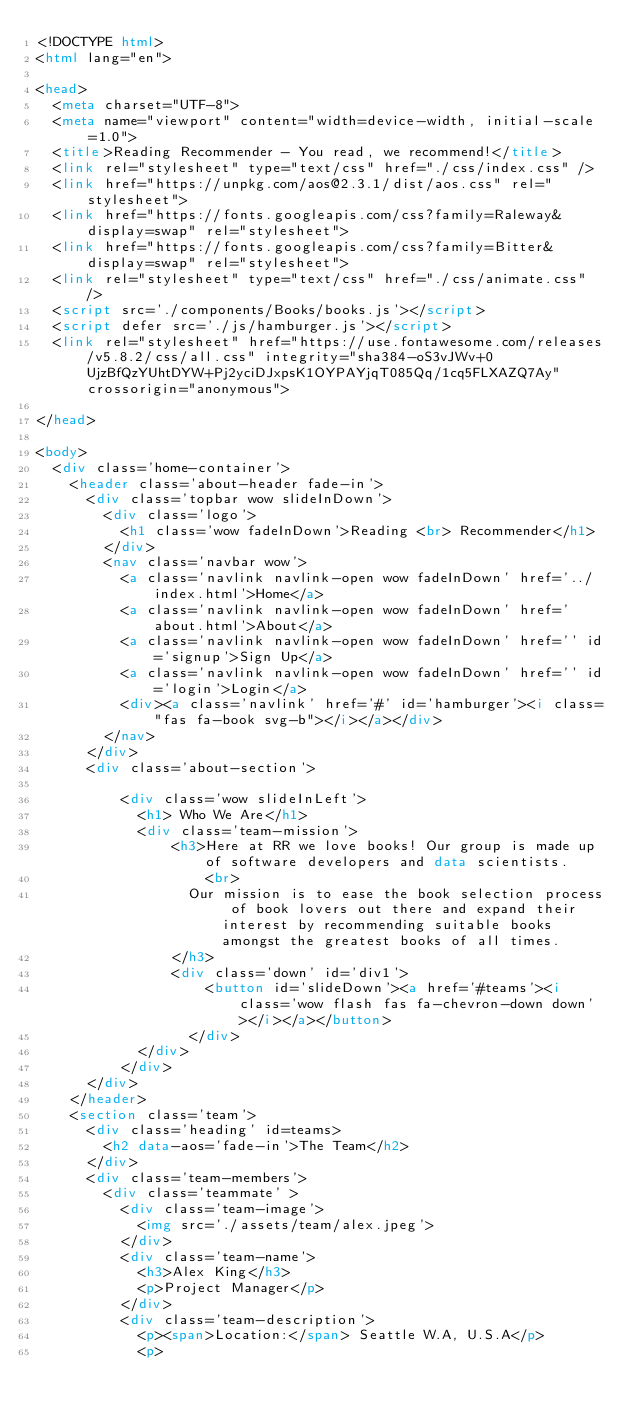Convert code to text. <code><loc_0><loc_0><loc_500><loc_500><_HTML_><!DOCTYPE html>
<html lang="en">

<head>
	<meta charset="UTF-8">
	<meta name="viewport" content="width=device-width, initial-scale=1.0">
	<title>Reading Recommender - You read, we recommend!</title>
	<link rel="stylesheet" type="text/css" href="./css/index.css" />
	<link href="https://unpkg.com/aos@2.3.1/dist/aos.css" rel="stylesheet">
	<link href="https://fonts.googleapis.com/css?family=Raleway&display=swap" rel="stylesheet">
	<link href="https://fonts.googleapis.com/css?family=Bitter&display=swap" rel="stylesheet">
	<link rel="stylesheet" type="text/css" href="./css/animate.css" />
	<script src='./components/Books/books.js'></script>
	<script defer src='./js/hamburger.js'></script>
	<link rel="stylesheet" href="https://use.fontawesome.com/releases/v5.8.2/css/all.css" integrity="sha384-oS3vJWv+0UjzBfQzYUhtDYW+Pj2yciDJxpsK1OYPAYjqT085Qq/1cq5FLXAZQ7Ay" crossorigin="anonymous">

</head>

<body>
	<div class='home-container'>
		<header class='about-header fade-in'>
			<div class='topbar wow slideInDown'>
				<div class='logo'>
					<h1 class='wow fadeInDown'>Reading <br> Recommender</h1>
				</div>
				<nav class='navbar wow'>
					<a class='navlink navlink-open wow fadeInDown' href='../index.html'>Home</a>
					<a class='navlink navlink-open wow fadeInDown' href='about.html'>About</a>
					<a class='navlink navlink-open wow fadeInDown' href='' id='signup'>Sign Up</a>
					<a class='navlink navlink-open wow fadeInDown' href='' id='login'>Login</a>
					<div><a class='navlink' href='#' id='hamburger'><i class="fas fa-book svg-b"></i></a></div>
				</nav>
			</div>
			<div class='about-section'>
			
					<div class='wow slideInLeft'>
						<h1> Who We Are</h1>
						<div class='team-mission'>
								<h3>Here at RR we love books! Our group is made up of software developers and data scientists.
										<br>
									Our mission is to ease the book selection process of book lovers out there and expand their interest by recommending suitable books amongst the greatest books of all times.
								</h3>
								<div class='down' id='div1'>
										<button id='slideDown'><a href='#teams'><i class='wow flash fas fa-chevron-down down'></i></a></button>
									</div> 
						</div>
					</div>
			</div>
		</header>
		<section class='team'>
			<div class='heading' id=teams>
				<h2 data-aos='fade-in'>The Team</h2>
			</div>
			<div class='team-members'>
				<div class='teammate' >
					<div class='team-image'>
						<img src='./assets/team/alex.jpeg'>
					</div>
					<div class='team-name'>
						<h3>Alex King</h3>
						<p>Project Manager</p>
					</div>
					<div class='team-description'>
						<p><span>Location:</span> Seattle W.A, U.S.A</p>
						<p></code> 